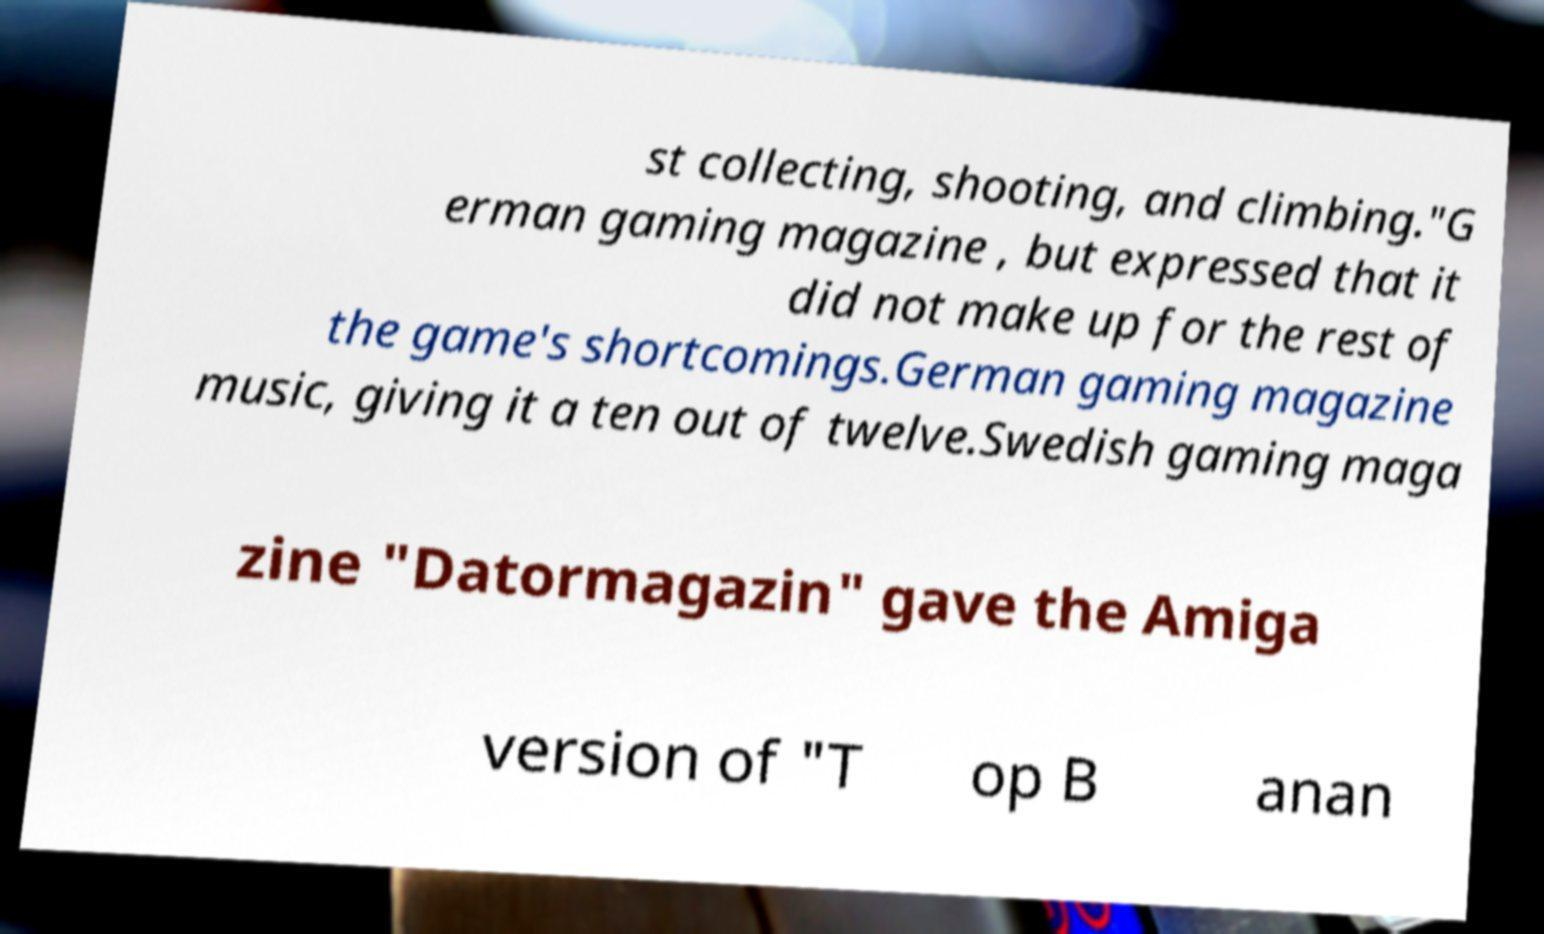I need the written content from this picture converted into text. Can you do that? st collecting, shooting, and climbing."G erman gaming magazine , but expressed that it did not make up for the rest of the game's shortcomings.German gaming magazine music, giving it a ten out of twelve.Swedish gaming maga zine "Datormagazin" gave the Amiga version of "T op B anan 